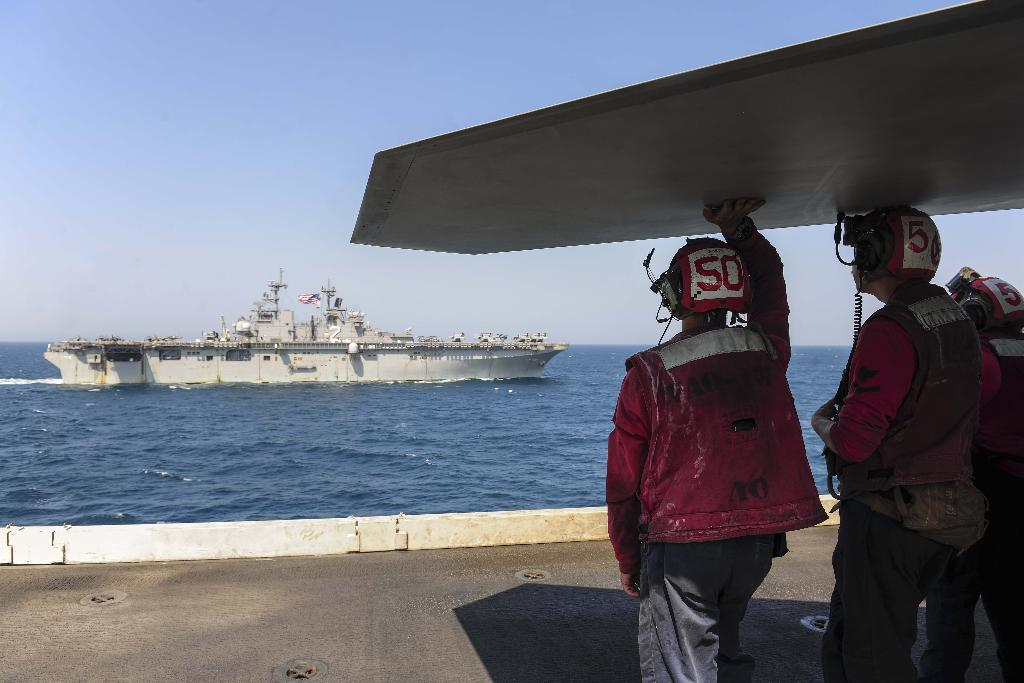<image>
Describe the image concisely. A person on the carrier crew wears a hat with number 50. 